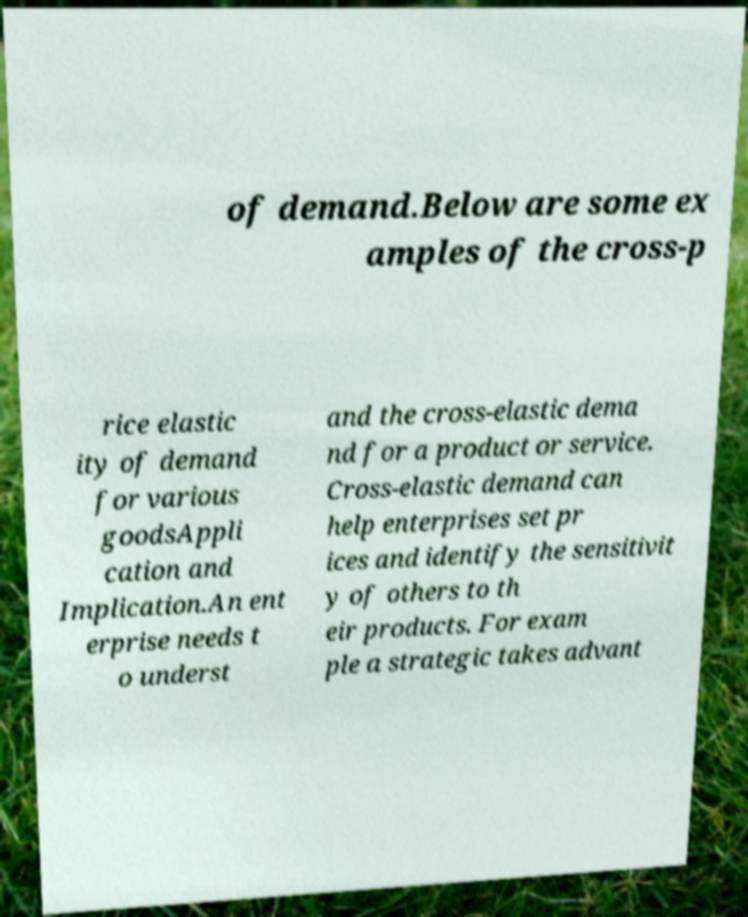For documentation purposes, I need the text within this image transcribed. Could you provide that? of demand.Below are some ex amples of the cross-p rice elastic ity of demand for various goodsAppli cation and Implication.An ent erprise needs t o underst and the cross-elastic dema nd for a product or service. Cross-elastic demand can help enterprises set pr ices and identify the sensitivit y of others to th eir products. For exam ple a strategic takes advant 